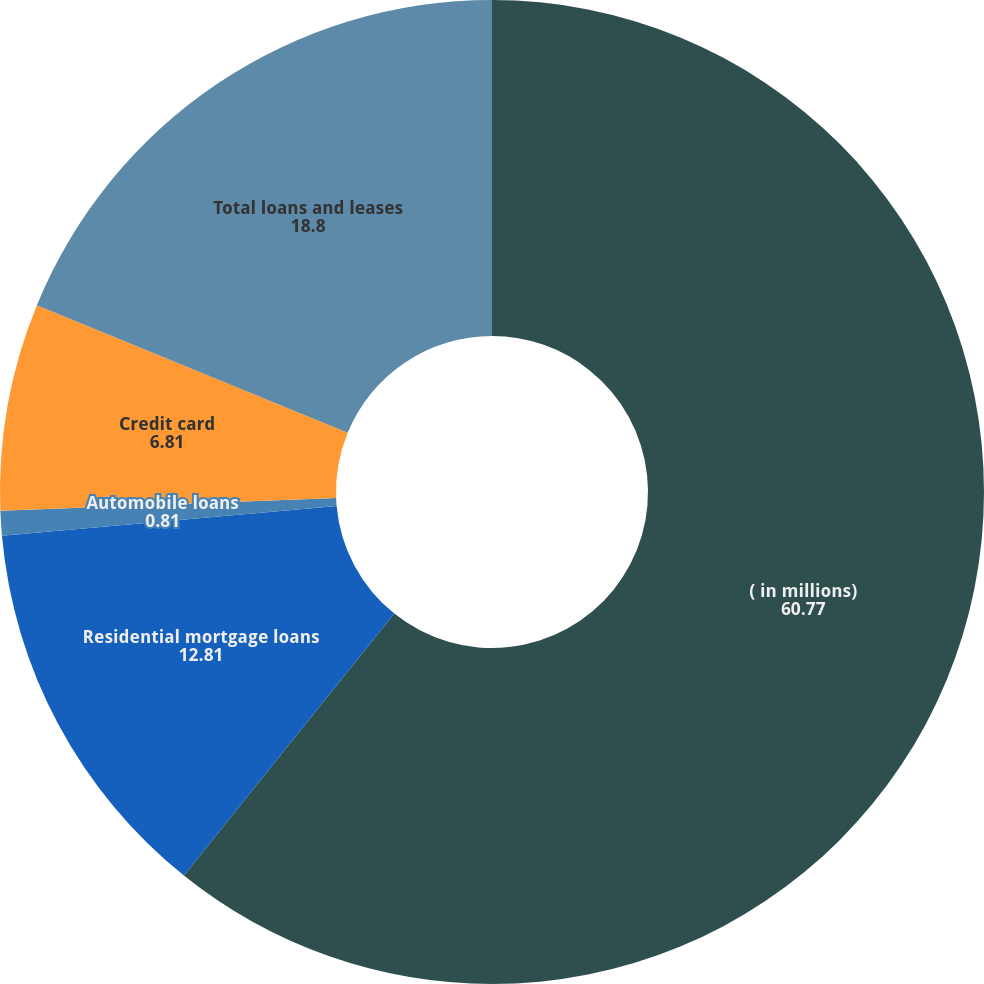Convert chart. <chart><loc_0><loc_0><loc_500><loc_500><pie_chart><fcel>( in millions)<fcel>Residential mortgage loans<fcel>Automobile loans<fcel>Credit card<fcel>Total loans and leases<nl><fcel>60.77%<fcel>12.81%<fcel>0.81%<fcel>6.81%<fcel>18.8%<nl></chart> 